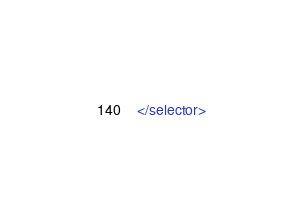<code> <loc_0><loc_0><loc_500><loc_500><_XML_>
</selector></code> 